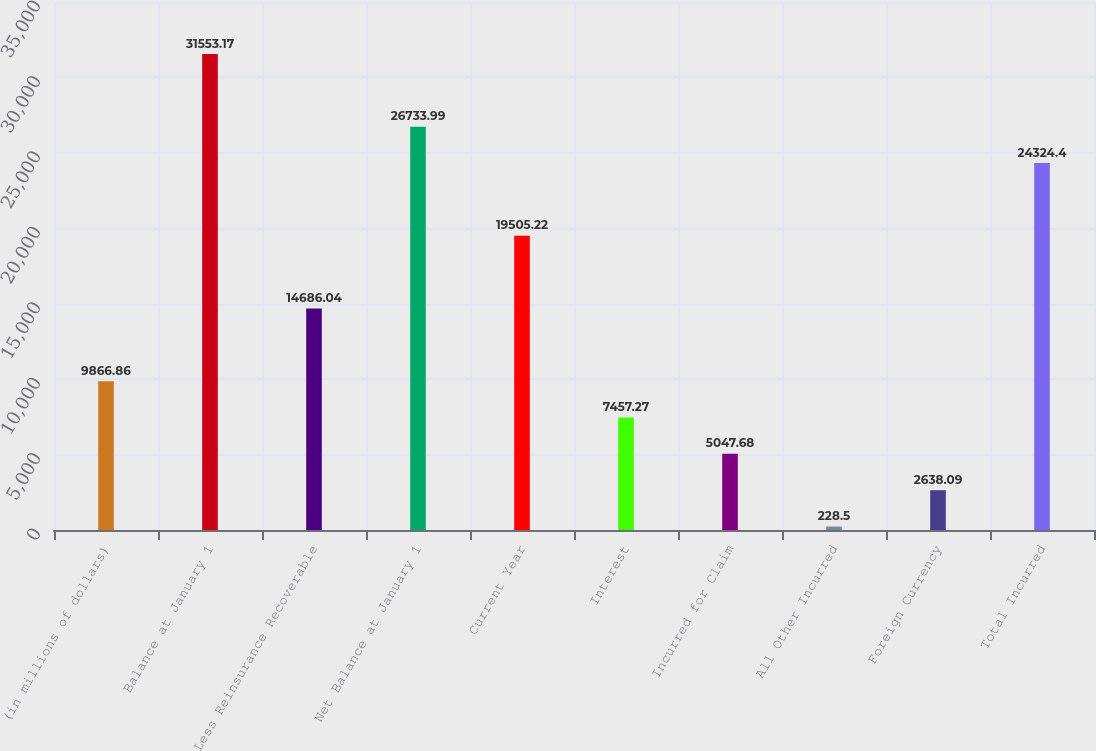<chart> <loc_0><loc_0><loc_500><loc_500><bar_chart><fcel>(in millions of dollars)<fcel>Balance at January 1<fcel>Less Reinsurance Recoverable<fcel>Net Balance at January 1<fcel>Current Year<fcel>Interest<fcel>Incurred for Claim<fcel>All Other Incurred<fcel>Foreign Currency<fcel>Total Incurred<nl><fcel>9866.86<fcel>31553.2<fcel>14686<fcel>26734<fcel>19505.2<fcel>7457.27<fcel>5047.68<fcel>228.5<fcel>2638.09<fcel>24324.4<nl></chart> 